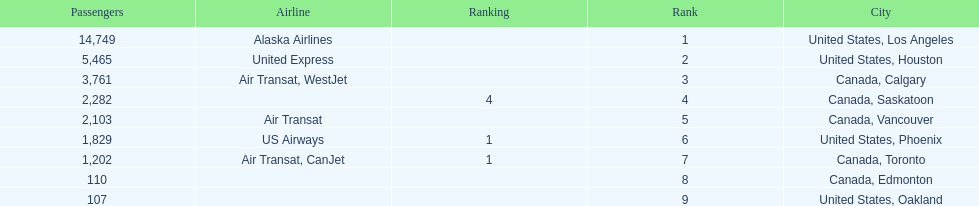Which canadian city had the most passengers traveling from manzanillo international airport in 2013? Calgary. Can you parse all the data within this table? {'header': ['Passengers', 'Airline', 'Ranking', 'Rank', 'City'], 'rows': [['14,749', 'Alaska Airlines', '', '1', 'United States, Los Angeles'], ['5,465', 'United Express', '', '2', 'United States, Houston'], ['3,761', 'Air Transat, WestJet', '', '3', 'Canada, Calgary'], ['2,282', '', '4', '4', 'Canada, Saskatoon'], ['2,103', 'Air Transat', '', '5', 'Canada, Vancouver'], ['1,829', 'US Airways', '1', '6', 'United States, Phoenix'], ['1,202', 'Air Transat, CanJet', '1', '7', 'Canada, Toronto'], ['110', '', '', '8', 'Canada, Edmonton'], ['107', '', '', '9', 'United States, Oakland']]} 